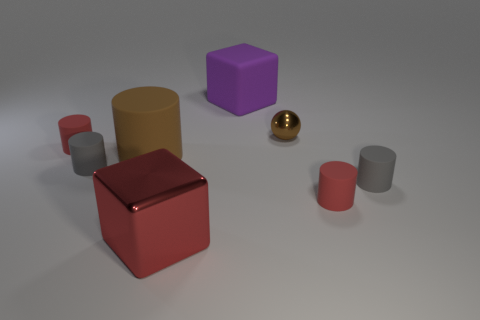Does the red metal thing have the same shape as the purple rubber object?
Offer a terse response. Yes. There is a red rubber cylinder that is on the left side of the large red block; how big is it?
Keep it short and to the point. Small. Are there any small cylinders of the same color as the metal block?
Provide a succinct answer. Yes. Does the gray rubber object that is right of the red metallic cube have the same size as the brown rubber thing?
Your answer should be very brief. No. What color is the big rubber cylinder?
Keep it short and to the point. Brown. There is a large matte object on the right side of the cube left of the purple cube; what color is it?
Give a very brief answer. Purple. Is there a cube made of the same material as the big cylinder?
Your answer should be compact. Yes. The purple object on the left side of the shiny object behind the big cylinder is made of what material?
Ensure brevity in your answer.  Rubber. How many matte objects are the same shape as the large red metallic object?
Offer a very short reply. 1. What is the shape of the purple matte object?
Your response must be concise. Cube. 